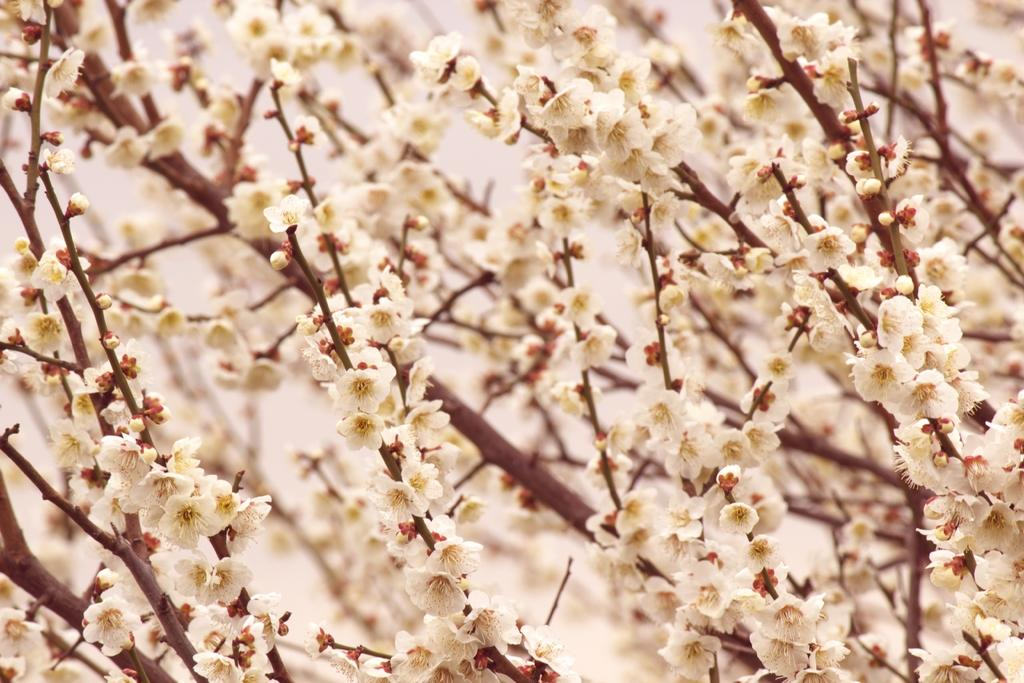What type of objects are present in the image? There are flowers in the image. Can you describe the colors of the flowers? The flowers are white and yellow in color. How many times have the flowers been folded in the image? The flowers have not been folded in the image, as they are not a piece of fabric or paper. 